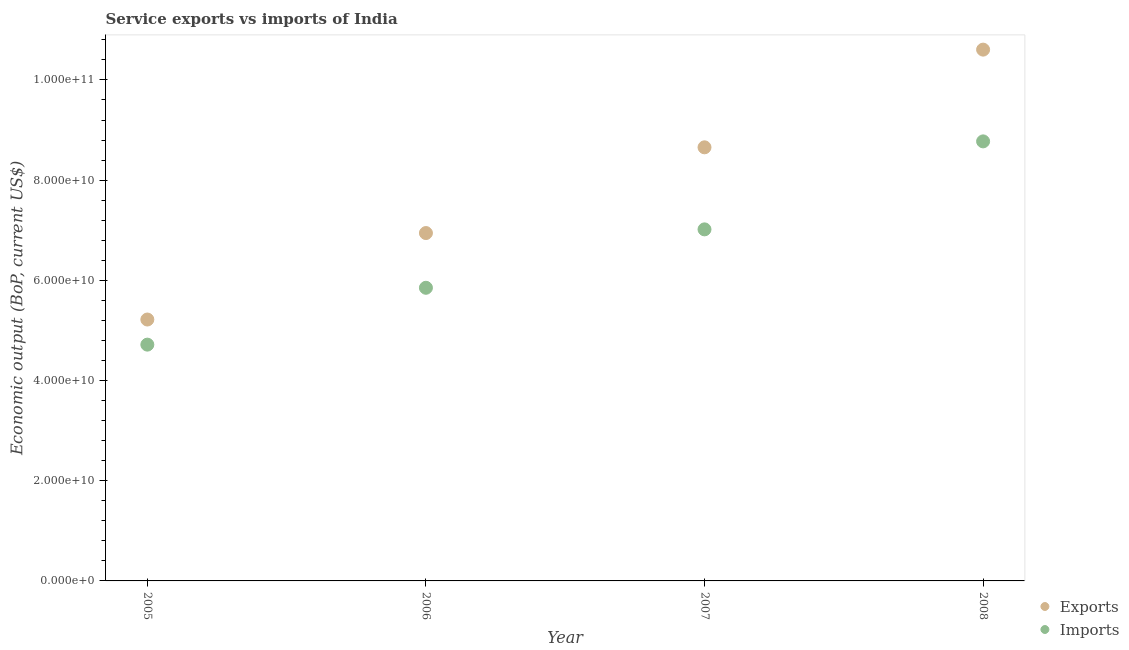How many different coloured dotlines are there?
Your answer should be compact. 2. What is the amount of service exports in 2005?
Your response must be concise. 5.22e+1. Across all years, what is the maximum amount of service exports?
Your response must be concise. 1.06e+11. Across all years, what is the minimum amount of service imports?
Your response must be concise. 4.72e+1. What is the total amount of service imports in the graph?
Give a very brief answer. 2.64e+11. What is the difference between the amount of service exports in 2006 and that in 2007?
Make the answer very short. -1.71e+1. What is the difference between the amount of service exports in 2006 and the amount of service imports in 2008?
Provide a succinct answer. -1.83e+1. What is the average amount of service imports per year?
Offer a terse response. 6.59e+1. In the year 2008, what is the difference between the amount of service exports and amount of service imports?
Give a very brief answer. 1.83e+1. In how many years, is the amount of service imports greater than 40000000000 US$?
Ensure brevity in your answer.  4. What is the ratio of the amount of service exports in 2007 to that in 2008?
Give a very brief answer. 0.82. What is the difference between the highest and the second highest amount of service imports?
Provide a short and direct response. 1.76e+1. What is the difference between the highest and the lowest amount of service imports?
Offer a very short reply. 4.06e+1. In how many years, is the amount of service exports greater than the average amount of service exports taken over all years?
Give a very brief answer. 2. Is the amount of service imports strictly greater than the amount of service exports over the years?
Offer a very short reply. No. How many years are there in the graph?
Your answer should be very brief. 4. Are the values on the major ticks of Y-axis written in scientific E-notation?
Offer a very short reply. Yes. Does the graph contain grids?
Your answer should be very brief. No. Where does the legend appear in the graph?
Your answer should be compact. Bottom right. How many legend labels are there?
Give a very brief answer. 2. What is the title of the graph?
Keep it short and to the point. Service exports vs imports of India. Does "Number of departures" appear as one of the legend labels in the graph?
Ensure brevity in your answer.  No. What is the label or title of the Y-axis?
Offer a very short reply. Economic output (BoP, current US$). What is the Economic output (BoP, current US$) in Exports in 2005?
Your answer should be compact. 5.22e+1. What is the Economic output (BoP, current US$) in Imports in 2005?
Provide a short and direct response. 4.72e+1. What is the Economic output (BoP, current US$) of Exports in 2006?
Your answer should be very brief. 6.94e+1. What is the Economic output (BoP, current US$) of Imports in 2006?
Offer a very short reply. 5.85e+1. What is the Economic output (BoP, current US$) in Exports in 2007?
Your answer should be very brief. 8.66e+1. What is the Economic output (BoP, current US$) of Imports in 2007?
Provide a succinct answer. 7.02e+1. What is the Economic output (BoP, current US$) in Exports in 2008?
Ensure brevity in your answer.  1.06e+11. What is the Economic output (BoP, current US$) in Imports in 2008?
Provide a succinct answer. 8.77e+1. Across all years, what is the maximum Economic output (BoP, current US$) of Exports?
Offer a very short reply. 1.06e+11. Across all years, what is the maximum Economic output (BoP, current US$) of Imports?
Offer a very short reply. 8.77e+1. Across all years, what is the minimum Economic output (BoP, current US$) of Exports?
Provide a succinct answer. 5.22e+1. Across all years, what is the minimum Economic output (BoP, current US$) in Imports?
Your answer should be compact. 4.72e+1. What is the total Economic output (BoP, current US$) in Exports in the graph?
Offer a very short reply. 3.14e+11. What is the total Economic output (BoP, current US$) of Imports in the graph?
Make the answer very short. 2.64e+11. What is the difference between the Economic output (BoP, current US$) of Exports in 2005 and that in 2006?
Offer a terse response. -1.73e+1. What is the difference between the Economic output (BoP, current US$) of Imports in 2005 and that in 2006?
Keep it short and to the point. -1.13e+1. What is the difference between the Economic output (BoP, current US$) of Exports in 2005 and that in 2007?
Offer a very short reply. -3.44e+1. What is the difference between the Economic output (BoP, current US$) of Imports in 2005 and that in 2007?
Provide a short and direct response. -2.30e+1. What is the difference between the Economic output (BoP, current US$) of Exports in 2005 and that in 2008?
Provide a short and direct response. -5.39e+1. What is the difference between the Economic output (BoP, current US$) in Imports in 2005 and that in 2008?
Ensure brevity in your answer.  -4.06e+1. What is the difference between the Economic output (BoP, current US$) in Exports in 2006 and that in 2007?
Keep it short and to the point. -1.71e+1. What is the difference between the Economic output (BoP, current US$) of Imports in 2006 and that in 2007?
Give a very brief answer. -1.17e+1. What is the difference between the Economic output (BoP, current US$) of Exports in 2006 and that in 2008?
Your answer should be very brief. -3.66e+1. What is the difference between the Economic output (BoP, current US$) in Imports in 2006 and that in 2008?
Provide a short and direct response. -2.92e+1. What is the difference between the Economic output (BoP, current US$) of Exports in 2007 and that in 2008?
Your answer should be compact. -1.95e+1. What is the difference between the Economic output (BoP, current US$) in Imports in 2007 and that in 2008?
Keep it short and to the point. -1.76e+1. What is the difference between the Economic output (BoP, current US$) of Exports in 2005 and the Economic output (BoP, current US$) of Imports in 2006?
Give a very brief answer. -6.34e+09. What is the difference between the Economic output (BoP, current US$) of Exports in 2005 and the Economic output (BoP, current US$) of Imports in 2007?
Offer a terse response. -1.80e+1. What is the difference between the Economic output (BoP, current US$) in Exports in 2005 and the Economic output (BoP, current US$) in Imports in 2008?
Your answer should be very brief. -3.56e+1. What is the difference between the Economic output (BoP, current US$) of Exports in 2006 and the Economic output (BoP, current US$) of Imports in 2007?
Keep it short and to the point. -7.35e+08. What is the difference between the Economic output (BoP, current US$) in Exports in 2006 and the Economic output (BoP, current US$) in Imports in 2008?
Provide a succinct answer. -1.83e+1. What is the difference between the Economic output (BoP, current US$) of Exports in 2007 and the Economic output (BoP, current US$) of Imports in 2008?
Offer a terse response. -1.19e+09. What is the average Economic output (BoP, current US$) in Exports per year?
Your answer should be compact. 7.86e+1. What is the average Economic output (BoP, current US$) of Imports per year?
Offer a very short reply. 6.59e+1. In the year 2005, what is the difference between the Economic output (BoP, current US$) in Exports and Economic output (BoP, current US$) in Imports?
Your answer should be compact. 5.01e+09. In the year 2006, what is the difference between the Economic output (BoP, current US$) of Exports and Economic output (BoP, current US$) of Imports?
Provide a short and direct response. 1.09e+1. In the year 2007, what is the difference between the Economic output (BoP, current US$) of Exports and Economic output (BoP, current US$) of Imports?
Provide a succinct answer. 1.64e+1. In the year 2008, what is the difference between the Economic output (BoP, current US$) of Exports and Economic output (BoP, current US$) of Imports?
Ensure brevity in your answer.  1.83e+1. What is the ratio of the Economic output (BoP, current US$) in Exports in 2005 to that in 2006?
Your answer should be compact. 0.75. What is the ratio of the Economic output (BoP, current US$) of Imports in 2005 to that in 2006?
Your response must be concise. 0.81. What is the ratio of the Economic output (BoP, current US$) of Exports in 2005 to that in 2007?
Offer a terse response. 0.6. What is the ratio of the Economic output (BoP, current US$) in Imports in 2005 to that in 2007?
Give a very brief answer. 0.67. What is the ratio of the Economic output (BoP, current US$) of Exports in 2005 to that in 2008?
Provide a succinct answer. 0.49. What is the ratio of the Economic output (BoP, current US$) in Imports in 2005 to that in 2008?
Your answer should be compact. 0.54. What is the ratio of the Economic output (BoP, current US$) in Exports in 2006 to that in 2007?
Offer a very short reply. 0.8. What is the ratio of the Economic output (BoP, current US$) in Imports in 2006 to that in 2007?
Your answer should be very brief. 0.83. What is the ratio of the Economic output (BoP, current US$) in Exports in 2006 to that in 2008?
Offer a terse response. 0.65. What is the ratio of the Economic output (BoP, current US$) in Imports in 2006 to that in 2008?
Your response must be concise. 0.67. What is the ratio of the Economic output (BoP, current US$) of Exports in 2007 to that in 2008?
Offer a very short reply. 0.82. What is the ratio of the Economic output (BoP, current US$) of Imports in 2007 to that in 2008?
Your answer should be compact. 0.8. What is the difference between the highest and the second highest Economic output (BoP, current US$) in Exports?
Your answer should be compact. 1.95e+1. What is the difference between the highest and the second highest Economic output (BoP, current US$) in Imports?
Make the answer very short. 1.76e+1. What is the difference between the highest and the lowest Economic output (BoP, current US$) of Exports?
Your answer should be compact. 5.39e+1. What is the difference between the highest and the lowest Economic output (BoP, current US$) in Imports?
Your answer should be very brief. 4.06e+1. 